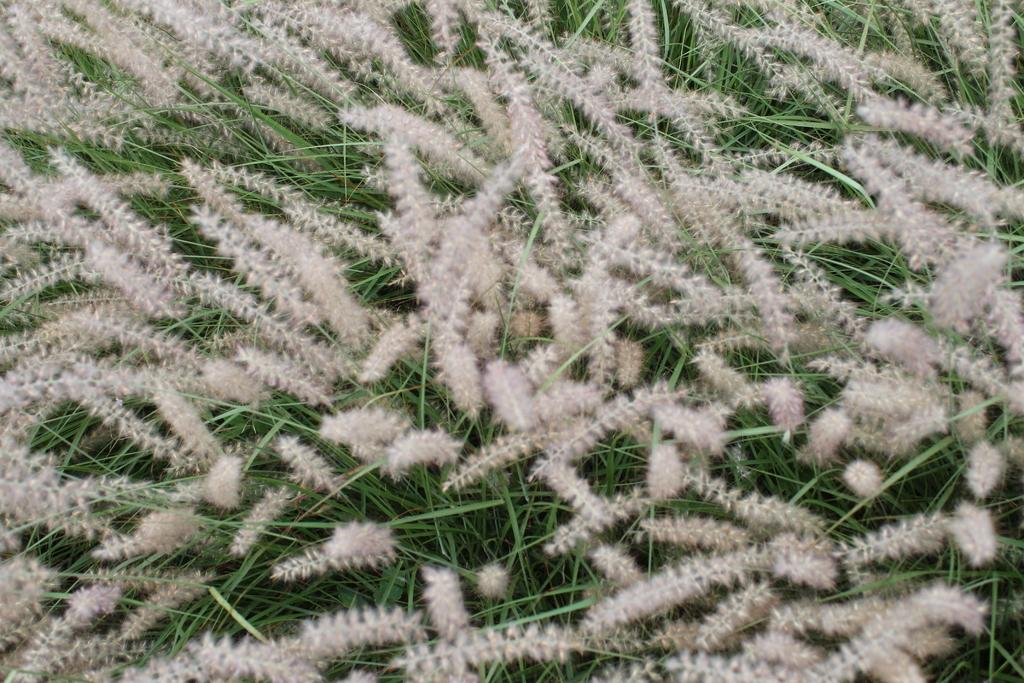What type of living organisms can be seen in the image? Flowers can be seen in the image. What type of box can be seen holding the flowers in the image? There is no box present in the image; only flowers are visible. What does the image of the flowers smell like? The image does not have a smell, as it is a visual representation. 